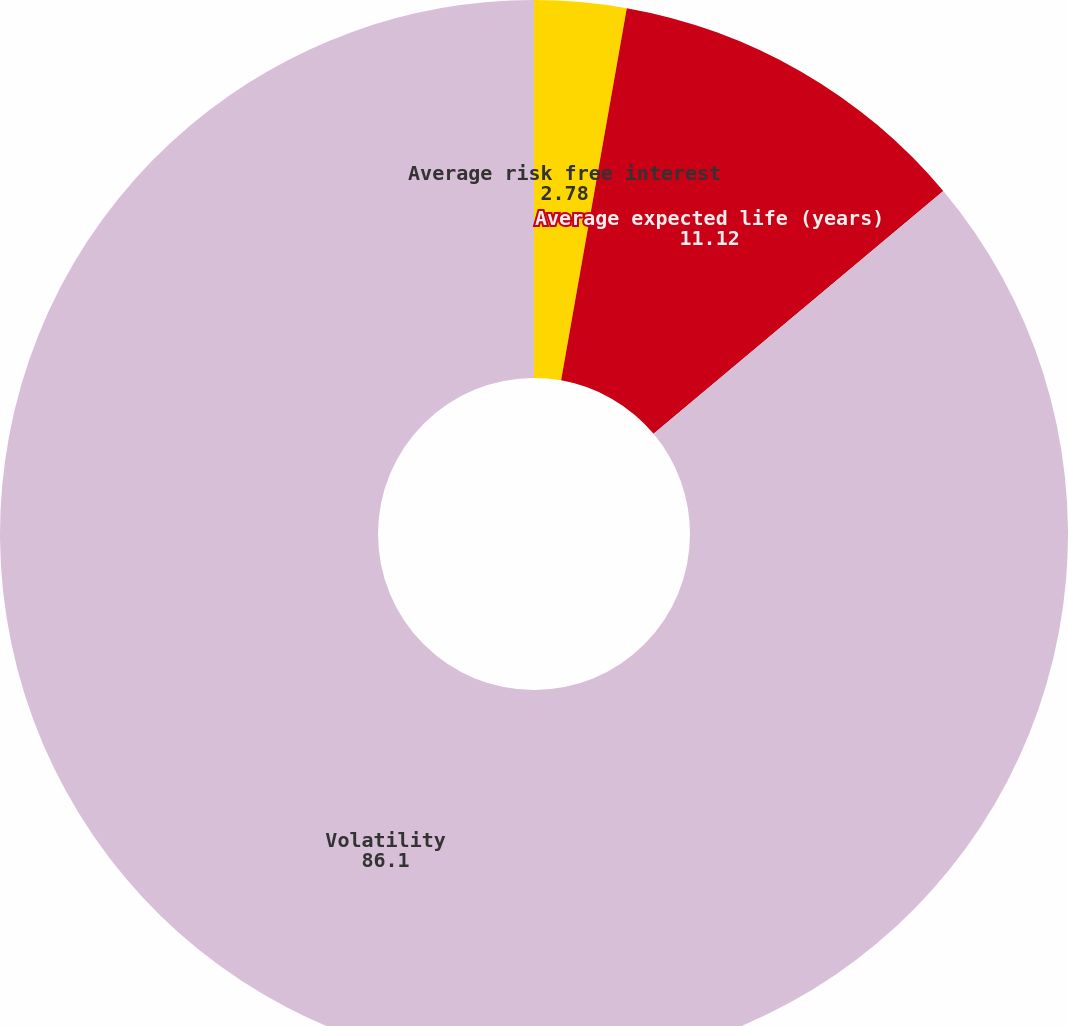Convert chart. <chart><loc_0><loc_0><loc_500><loc_500><pie_chart><fcel>Average risk free interest<fcel>Average expected life (years)<fcel>Volatility<nl><fcel>2.78%<fcel>11.12%<fcel>86.1%<nl></chart> 